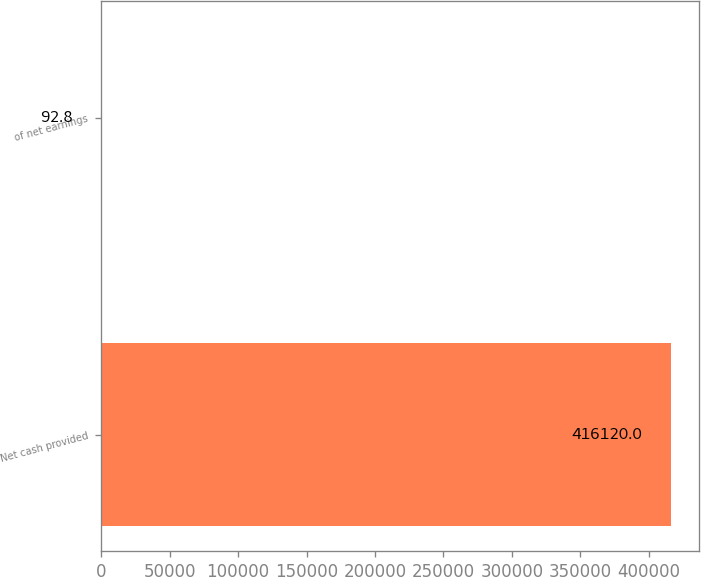Convert chart to OTSL. <chart><loc_0><loc_0><loc_500><loc_500><bar_chart><fcel>Net cash provided<fcel>of net earnings<nl><fcel>416120<fcel>92.8<nl></chart> 